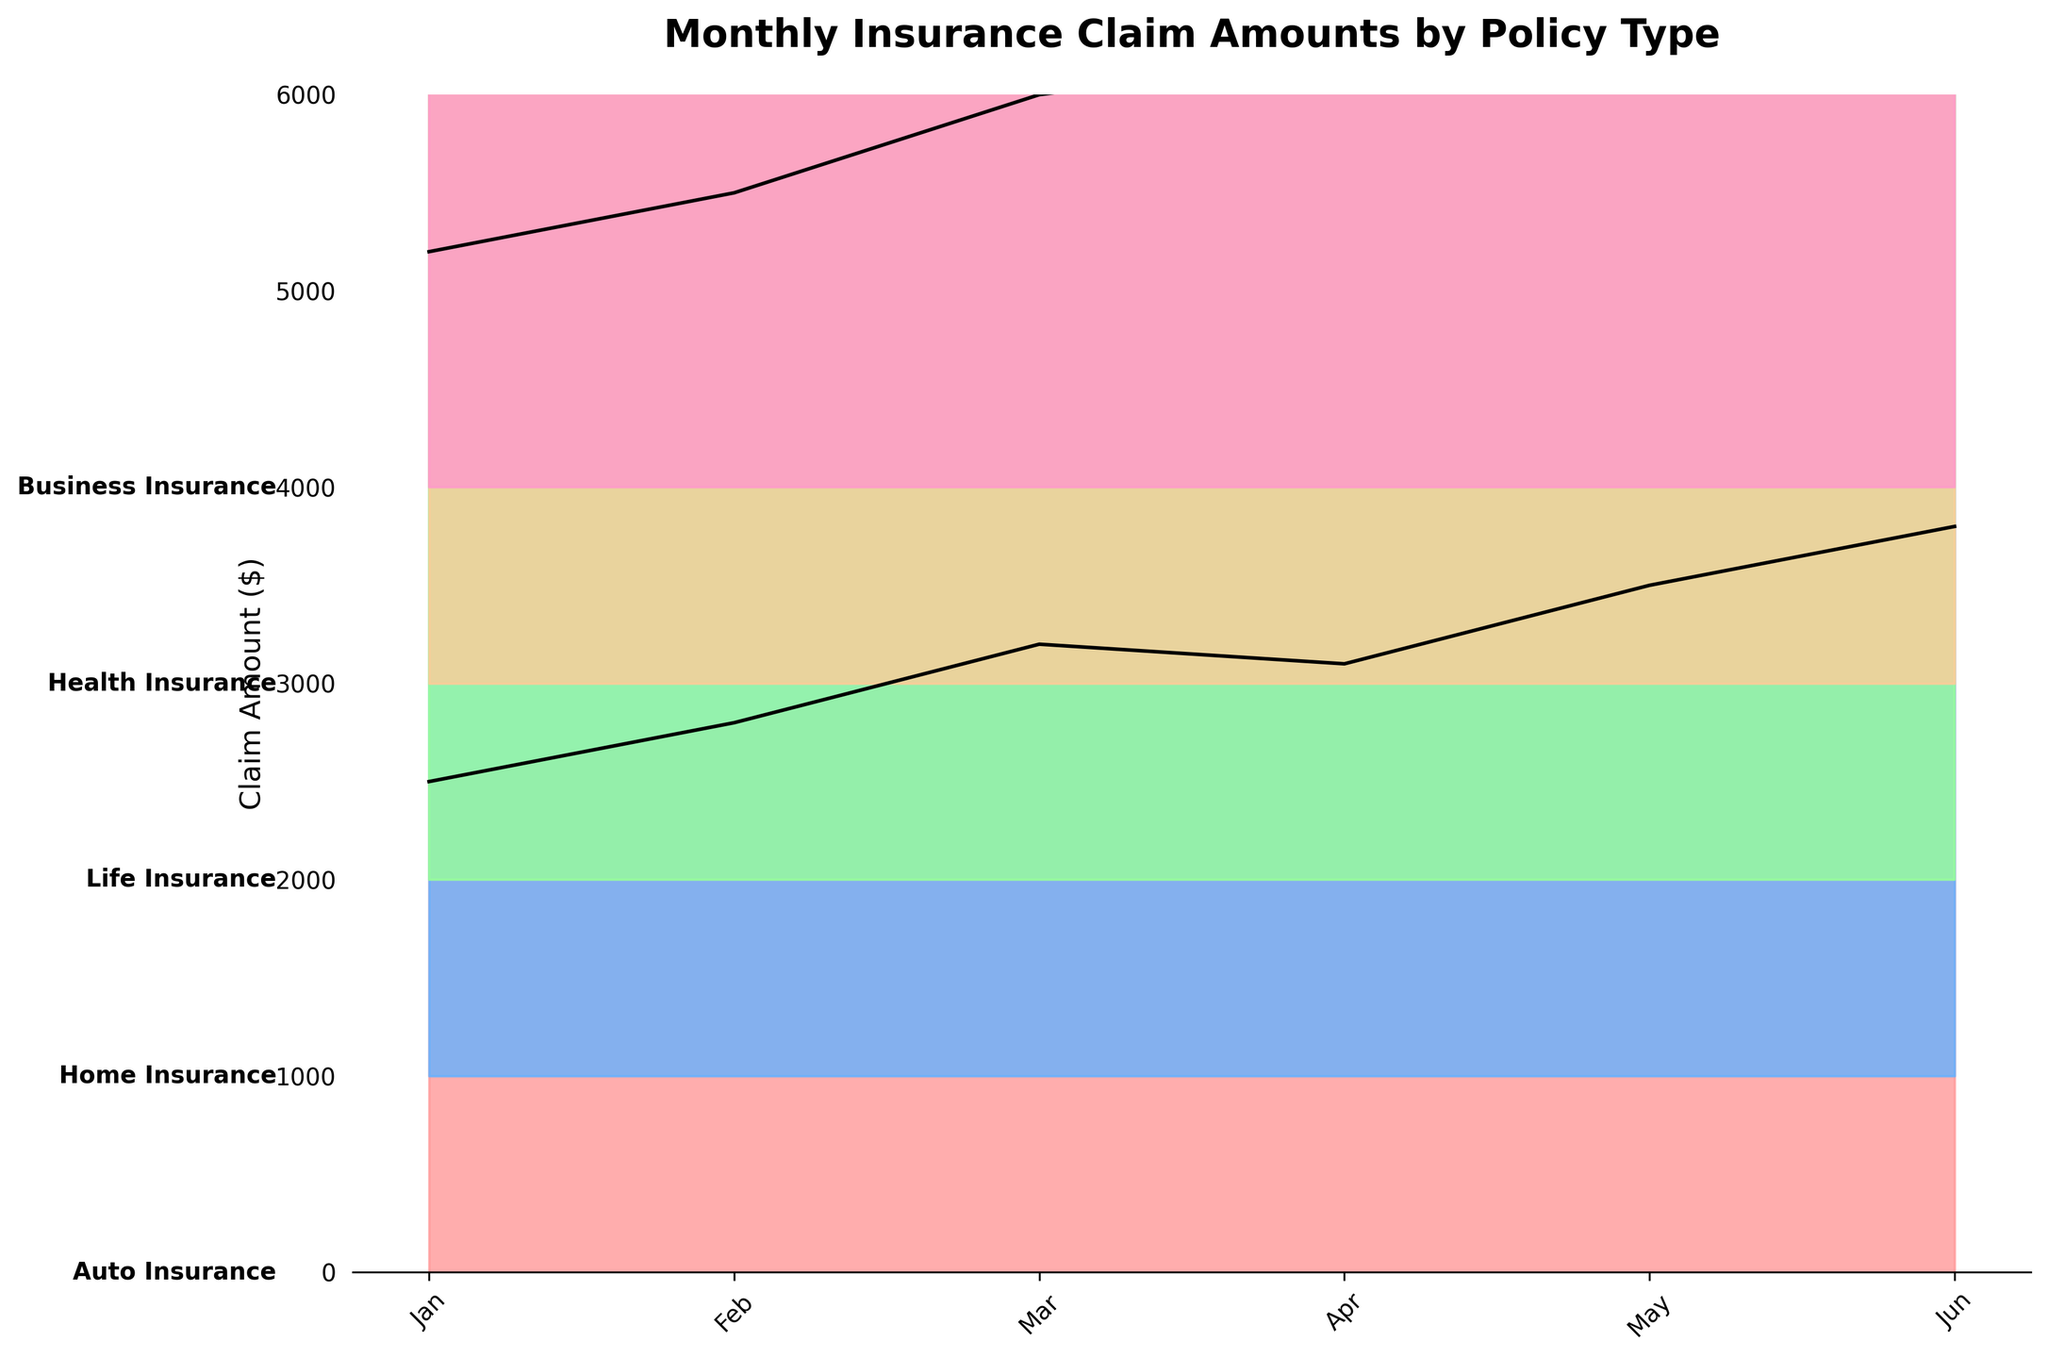Which policy type has the highest maximum monthly claim amount? By looking at the highest point reached by each colored ridge in the plot, it is clear that the "Life Insurance" type has the highest maximum monthly claim amount since its ridge extends higher up the y-axis than any other policy type.
Answer: Life Insurance Which month saw the highest claim amount for Auto Insurance? For Auto Insurance, trace the ridge corresponding to it across the months. The highest point on this ridge occurs in June, indicating that June saw the highest claim amount for Auto Insurance.
Answer: June Which policy type consistently has the lowest claim amounts across all months? Compare the positions of the ridges for each policy type. The ridge of Auto Insurance is the lowest across all months, indicating it consistently has the lowest claim amounts.
Answer: Auto Insurance How does the claim amount for Health Insurance in May compare to the claim amount for Business Insurance in April? Look at the ridges for Health Insurance and Business Insurance specifically at May and April. The Health Insurance ridge in May is slightly higher than the Business Insurance ridge in April.
Answer: Health Insurance in May is higher What is the average claim amount for Home Insurance from January to June? Sum the Home Insurance claim amounts for each month from January to June: 4200 + 4500 + 5000 + 5200 + 5800 + 6200 = 30900. The average is obtained by dividing this sum by 6.
Answer: 5150 Which policy type shows the most rapid increase in claims from January to June? Observe the slopes of the ridges from January to June. The "Home Insurance" ridge shows a steep upward trend, indicating the most rapid increase.
Answer: Home Insurance How does the claim amount for Life Insurance in February compare to the claim amount for Health Insurance in June? Locate the February ridge height for Life Insurance and compare it to the June ridge height for Health Insurance. The claim amount for Life Insurance in February is clearly higher.
Answer: Life Insurance in February is higher Which month had the highest average claim amount across all policy types? For each month, visually average the heights of all ridges. The month of June appears to have the highest overall ridge heights across all policy types, indicating the highest average claim amount.
Answer: June What is the total claim amount for Business Insurance over the six-month period? Sum the monthly claim amounts for Business Insurance: 6000 + 6500 + 7000 + 7500 + 8000 + 8500 = 43500.
Answer: 43500 Do Auto Insurance and Health Insurance show similar trends in claim amounts over time? Compare the general patterns in heights for Auto Insurance and Health Insurance ridges across months. While Health Insurance shows a consistent rise, Auto Insurance does not display a similar trend, indicating differing trends.
Answer: No 